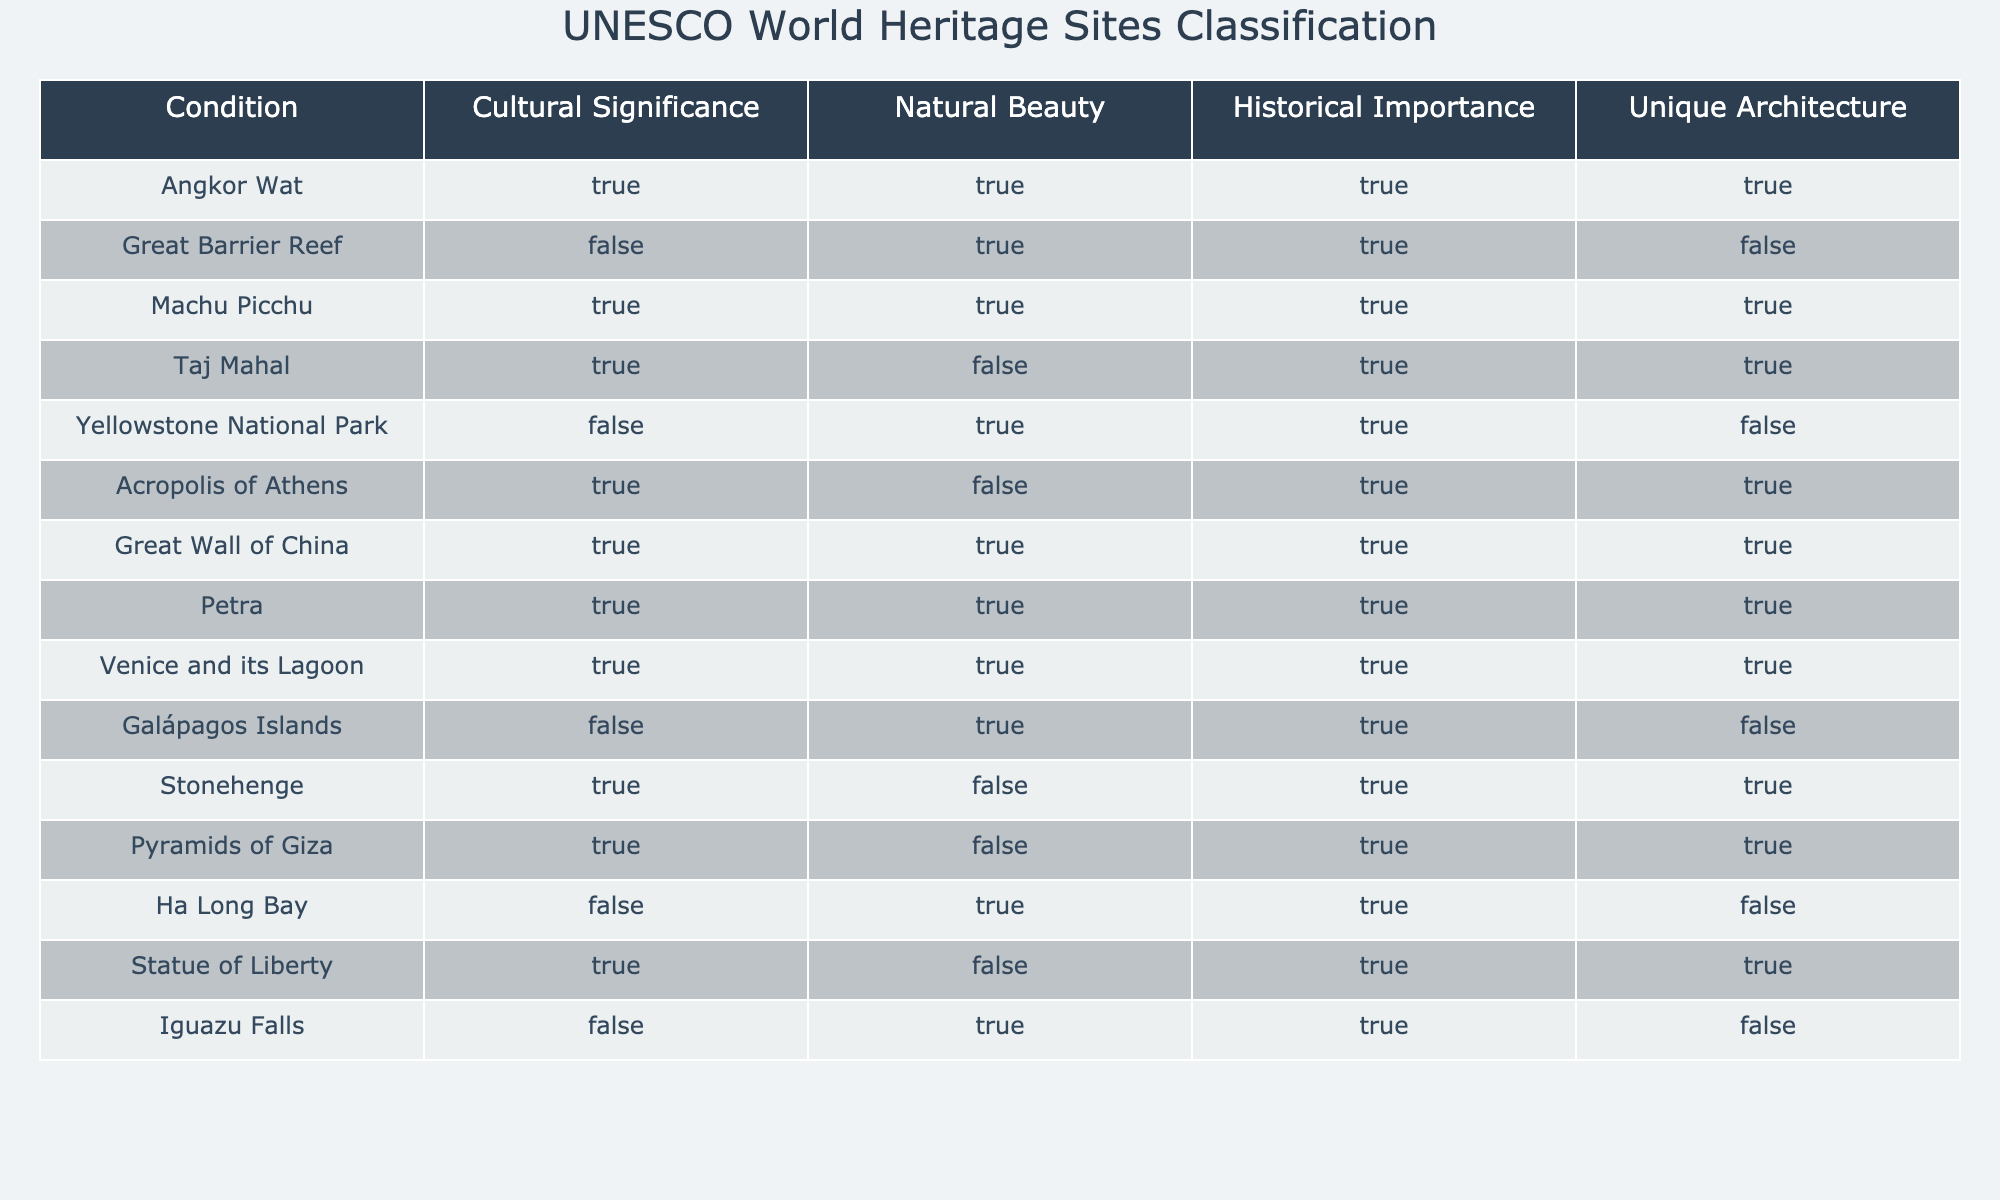What is the cultural significance of the Great Barrier Reef? The Great Barrier Reef is classified as having no cultural significance, as indicated by the table where "Cultural Significance" is marked as FALSE.
Answer: FALSE How many sites have unique architecture? To find the number of sites with unique architecture, we count the rows in the "Unique Architecture" column where the value is TRUE. The sites with unique architecture are Angkor Wat, Machu Picchu, Taj Mahal, Acropolis of Athens, Great Wall of China, Petra, Venice and its Lagoon, Stonehenge, and Pyramids of Giza. Therefore, there are 9 sites.
Answer: 9 Is the Taj Mahal recognized for its natural beauty? The table indicates that the Taj Mahal has a "Natural Beauty" classification marked as FALSE. Thus, it is not recognized for its natural beauty.
Answer: FALSE Which site has both cultural significance and historical importance but lacks unique architecture? Looking at the table, the Acropolis of Athens fits this description as it has TRUE values for "Cultural Significance" and "Historical Importance," while it has FALSE for "Unique Architecture."
Answer: Acropolis of Athens How many sites are both culturally significant and have natural beauty? We look for sites where both "Cultural Significance" and "Natural Beauty" are TRUE. The sites meeting this criterion are Angkor Wat, Machu Picchu, Great Wall of China, Petra, and Venice and its Lagoon. Counting these gives us a total of 5 sites.
Answer: 5 Are there more sites recognized for historical importance than for unique architecture? A count shows 10 sites with a TRUE value for historical importance (Angkor Wat, Great Barrier Reef, Machu Picchu, Taj Mahal, Yellowstone National Park, Acropolis of Athens, Great Wall of China, Petra, Venice and its Lagoon, Stonehenge, Pyramids of Giza, Statue of Liberty, Iguazu Falls) versus 9 sites for unique architecture. Since 10 is greater than 9, the answer is true.
Answer: TRUE Which site has historical importance but is not recognized for cultural significance? The table shows several sites with TRUE for historical importance but FALSE for cultural significance. One such example is the Great Barrier Reef, as it has FALSE for "Cultural Significance" and TRUE for "Historical Importance."
Answer: Great Barrier Reef What is the total number of sites listed in the table? We can calculate the number of sites by counting the rows in the table. The total count gives us 14 sites.
Answer: 14 How many sites are both natural wonders and of historical importance? By examining the "Natural Beauty" and "Historical Importance" columns, we can identify sites with TRUE values in both categories. The sites fitting this description are Machu Picchu, Yellowstone National Park, Great Wall of China, Petra, and Iguazu Falls, totaling 5.
Answer: 5 